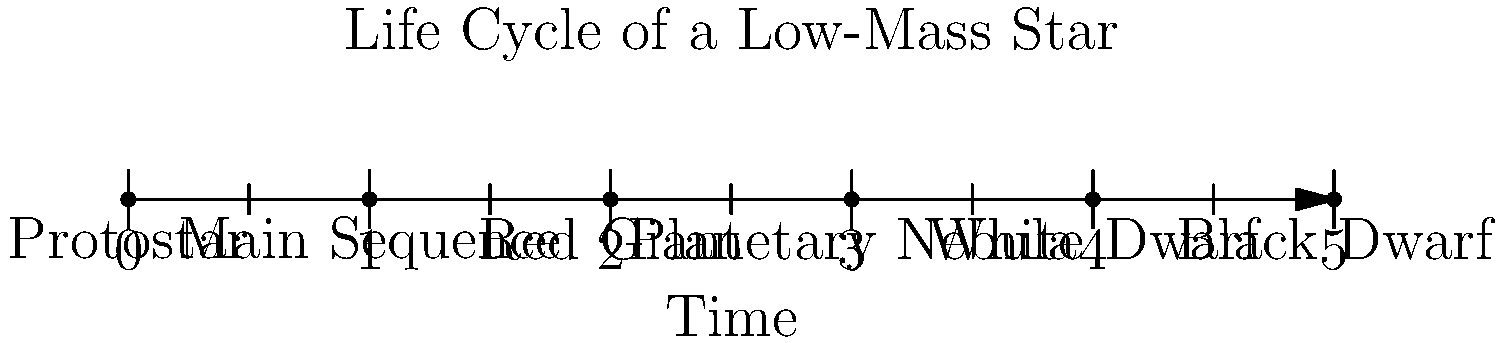In the context of promoting STEM education in a low-income school, you want to explain the life cycle of a low-mass star to your students. Using the timeline provided, which stage represents the longest period in a star's life, and why is this information important for students to understand? To answer this question, let's break down the life cycle of a low-mass star and consider the importance of each stage:

1. Protostar: This is the initial stage where a cloud of gas and dust collapses under gravity.
2. Main Sequence: This is the longest stage in a star's life. During this phase, the star fuses hydrogen into helium in its core, maintaining a stable state for billions of years.
3. Red Giant: As the hydrogen in the core is depleted, the star expands and cools, becoming a red giant.
4. Planetary Nebula: The outer layers of the star are ejected, forming a beautiful nebula.
5. White Dwarf: The remaining core of the star, no longer undergoing fusion, slowly cools over billions of years.
6. Black Dwarf: The theoretical final stage where the white dwarf has cooled completely (has not yet occurred in our universe due to its age).

The Main Sequence stage represents the longest period in a star's life. This is important for students to understand because:

1. It demonstrates the concept of stability in nature and how energy production can maintain equilibrium over long periods.
2. It helps students grasp the vast timescales involved in astronomical processes, enhancing their perspective on time and change.
3. Understanding stellar lifecycles can spark interest in STEM fields, particularly physics and astronomy, potentially opening up career paths for students from low-income backgrounds.
4. It provides context for understanding our own Sun, which is currently in its Main Sequence stage, and its importance to life on Earth.
5. This knowledge can be a starting point for discussions about energy production, nuclear fusion, and potential future energy sources for humanity.

By understanding these concepts, students can develop critical thinking skills and a deeper appreciation for the universe and scientific inquiry.
Answer: Main Sequence; longest stability promotes STEM interest and understanding of cosmic timescales. 